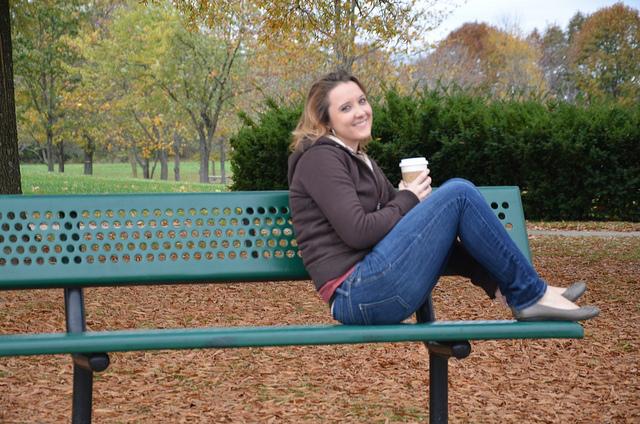What is on the bench next to the woman?
Quick response, please. Nothing. What is the person doing?
Give a very brief answer. Sitting. Is the bench made of wood or metal?
Be succinct. Metal. Is the woman in this picture smiling?
Give a very brief answer. Yes. Is the girl wearing flip flops?
Concise answer only. No. What is the bench made of?
Write a very short answer. Metal. Is the woman looking at the sky?
Concise answer only. No. What season does it appear to be?
Short answer required. Fall. What gender is the person on the bench?
Concise answer only. Female. Is the girl using a laptop?
Concise answer only. No. Is the woman drinking coffee?
Keep it brief. Yes. What nationality is the women that is sitting on bench?
Quick response, please. American. Approximately how high are the heels of the woman's shoe?
Short answer required. Low. What is on the bench?
Give a very brief answer. Woman. 